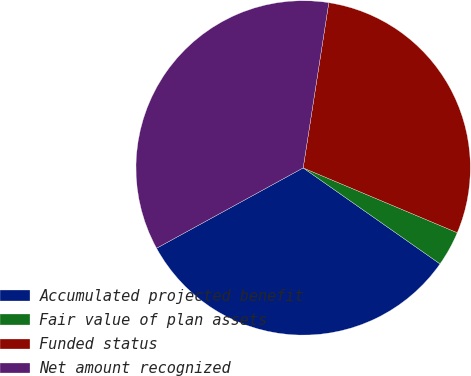Convert chart. <chart><loc_0><loc_0><loc_500><loc_500><pie_chart><fcel>Accumulated projected benefit<fcel>Fair value of plan assets<fcel>Funded status<fcel>Net amount recognized<nl><fcel>32.29%<fcel>3.4%<fcel>28.89%<fcel>35.43%<nl></chart> 